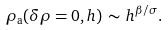Convert formula to latex. <formula><loc_0><loc_0><loc_500><loc_500>\rho _ { \text {a} } ( \delta \rho = 0 , h ) \, \sim \, h ^ { \beta / \sigma } .</formula> 